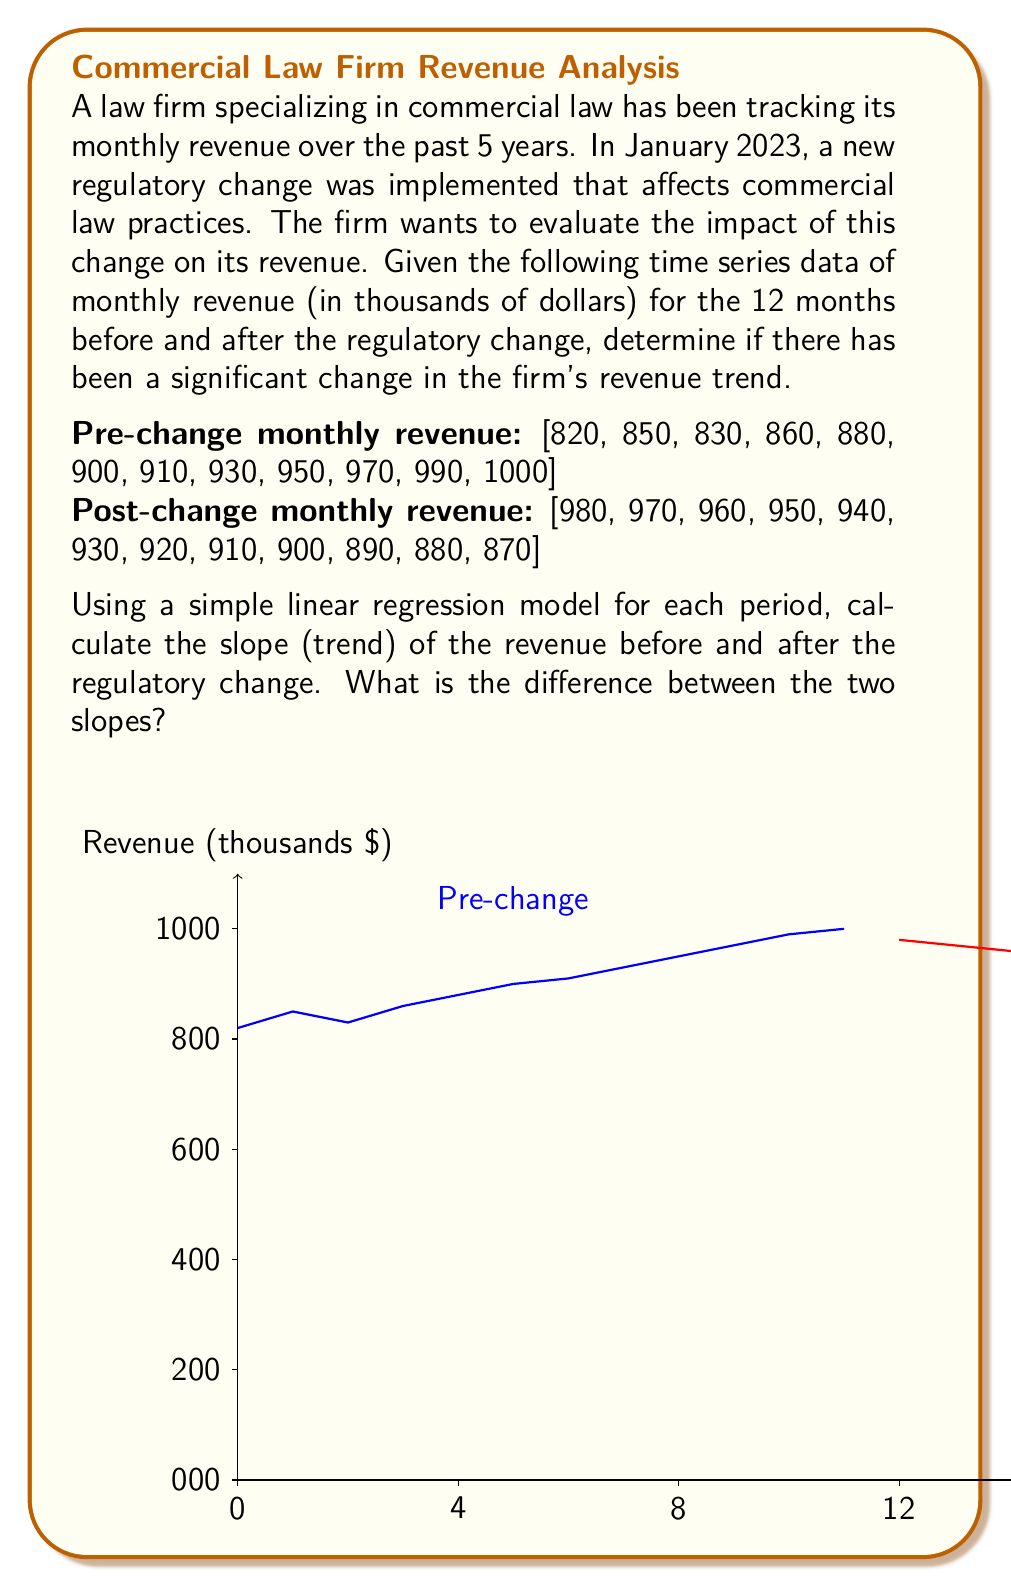Teach me how to tackle this problem. To evaluate the impact of the regulatory change on the firm's revenue, we'll use simple linear regression to calculate the slope (trend) of the revenue before and after the change.

For a simple linear regression model $y = mx + b$, where $y$ is the revenue and $x$ is the time (month number), we can calculate the slope $m$ using the formula:

$$ m = \frac{n\sum xy - \sum x \sum y}{n\sum x^2 - (\sum x)^2} $$

Where $n$ is the number of data points.

Step 1: Calculate the slope for pre-change data
$x = [1, 2, ..., 12]$
$y = [820, 850, 830, 860, 880, 900, 910, 930, 950, 970, 990, 1000]$

$n = 12$
$\sum x = 78$
$\sum y = 10890$
$\sum xy = 71280$
$\sum x^2 = 650$

$m_{pre} = \frac{12(71280) - 78(10890)}{12(650) - 78^2} \approx 16.22$

Step 2: Calculate the slope for post-change data
$x = [1, 2, ..., 12]$
$y = [980, 970, 960, 950, 940, 930, 920, 910, 900, 890, 880, 870]$

$n = 12$
$\sum x = 78$
$\sum y = 11100$
$\sum xy = 70980$
$\sum x^2 = 650$

$m_{post} = \frac{12(70980) - 78(11100)}{12(650) - 78^2} = -10$

Step 3: Calculate the difference between slopes
$\Delta m = m_{post} - m_{pre} = -10 - 16.22 = -26.22$

The negative value indicates a significant change from a positive trend to a negative trend after the regulatory change.
Answer: $-26.22$ thousand dollars per month 